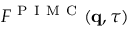Convert formula to latex. <formula><loc_0><loc_0><loc_500><loc_500>F ^ { P I M C } ( q , \tau )</formula> 